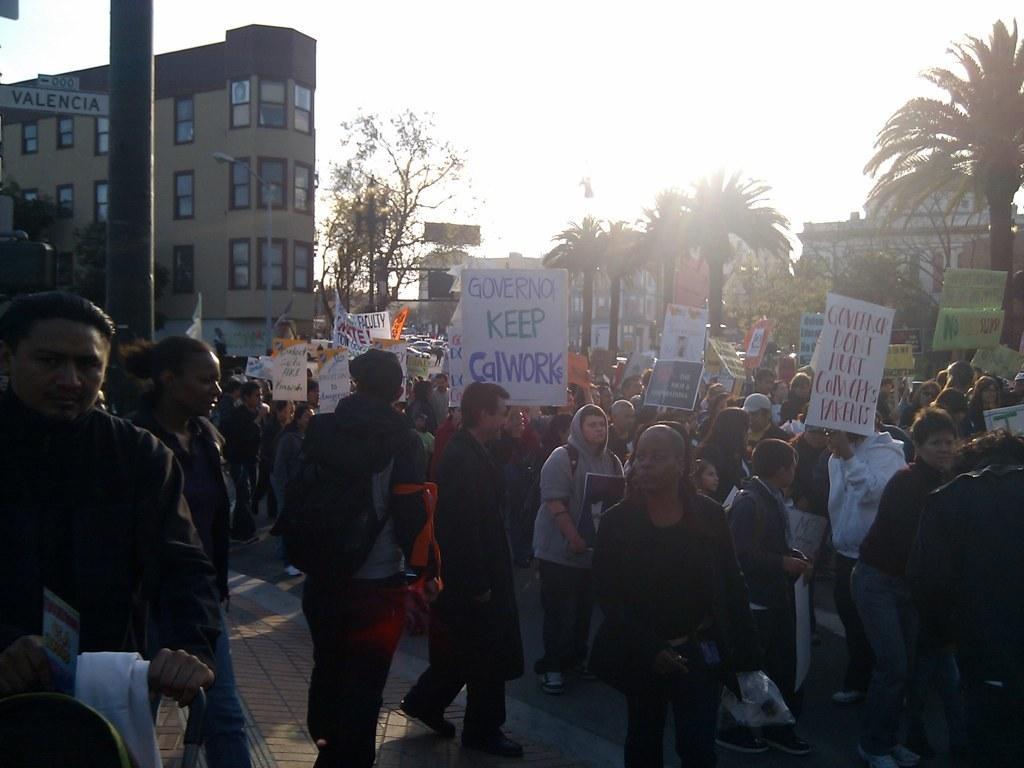How would you summarize this image in a sentence or two? In this image there are people holding placards, trees in the foreground. There are trees and buildings in the background. There is a road at the bottom. And there is a sky at the top. 